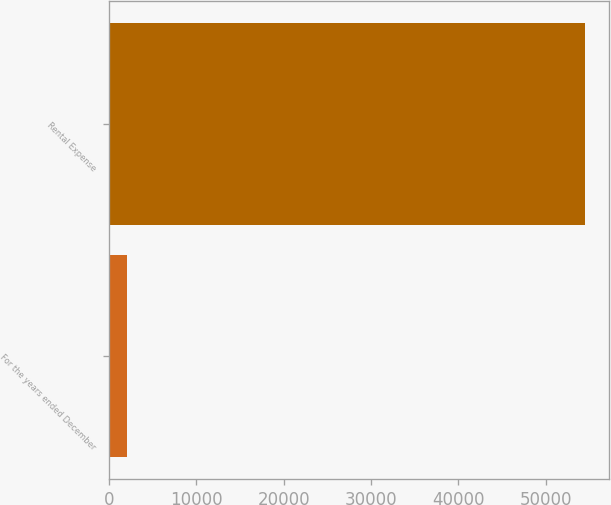<chart> <loc_0><loc_0><loc_500><loc_500><bar_chart><fcel>For the years ended December<fcel>Rental Expense<nl><fcel>2014<fcel>54487<nl></chart> 